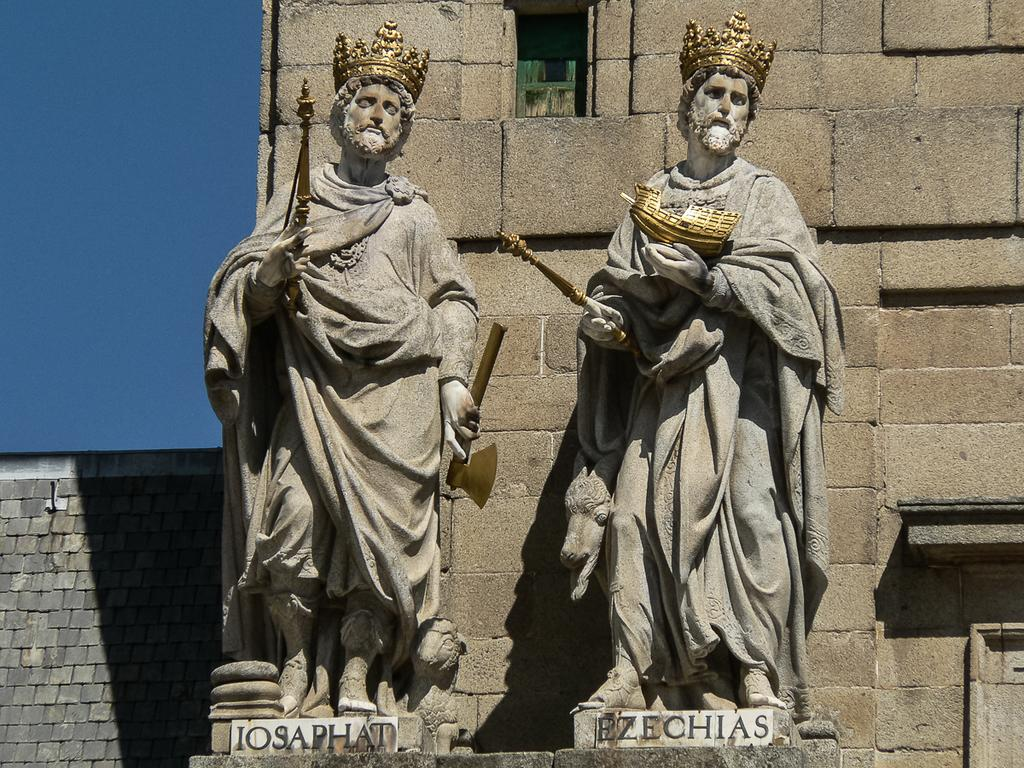What type of art is present in the image? There are sculptures in the image. Do the sculptures have any identifying features? Yes, the sculptures have names. What is located behind the sculptures in the image? There is a wall behind the sculptures. What direction are the cars facing in the image? There are no cars present in the image; it features sculptures with names and a wall in the background. 